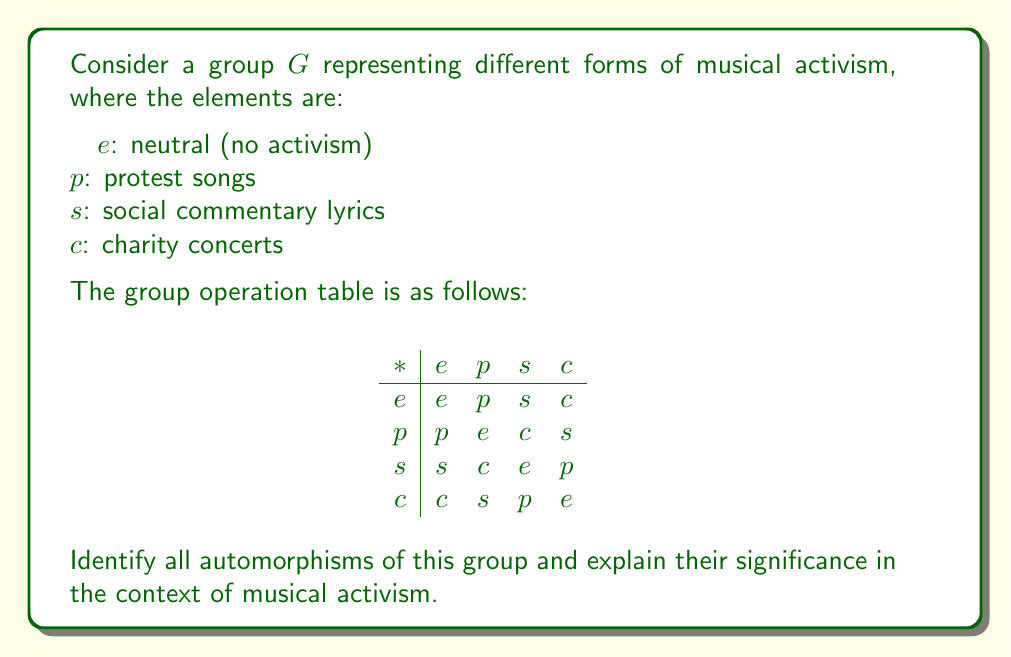Show me your answer to this math problem. To solve this problem, we need to follow these steps:

1) First, we need to understand what an automorphism is. An automorphism is a bijective homomorphism from a group to itself. In simpler terms, it's a way of rearranging the elements of the group while preserving the group structure.

2) We can see that this group is isomorphic to the Klein four-group $V_4$. This is because it's abelian, every non-identity element has order 2, and $e$ is the identity.

3) To find the automorphisms, we need to consider all possible permutations of the non-identity elements $(p, s, c)$ that preserve the group structure.

4) The identity mapping $(e)(p)(s)(c)$ is always an automorphism.

5) We can swap any two non-identity elements while fixing the third:
   $(e)(ps)(c)$
   $(e)(pc)(s)$
   $(e)(p)(sc)$

6) We can also cycle all three non-identity elements:
   $(e)(psc)$
   $(e)(pcs)$

7) In total, we have 6 automorphisms.

In the context of musical activism:
- The identity automorphism represents maintaining the current forms of activism.
- Swapping two forms (like protest songs and social commentary) suggests these forms can be interchangeable in their impact.
- Cycling all three forms implies that each form can take on the role of another in a cyclic manner, suggesting a fluid nature of musical activism where different approaches can lead to similar outcomes.

This analysis shows that different forms of musical activism are interconnected and can often serve similar purposes in driving social change.
Answer: The group $G$ has 6 automorphisms:

1) $(e)(p)(s)(c)$
2) $(e)(ps)(c)$
3) $(e)(pc)(s)$
4) $(e)(p)(sc)$
5) $(e)(psc)$
6) $(e)(pcs)$

These automorphisms demonstrate the interconnected nature of different forms of musical activism, showing how various approaches can be equivalent or interchangeable in their impact on social change. 